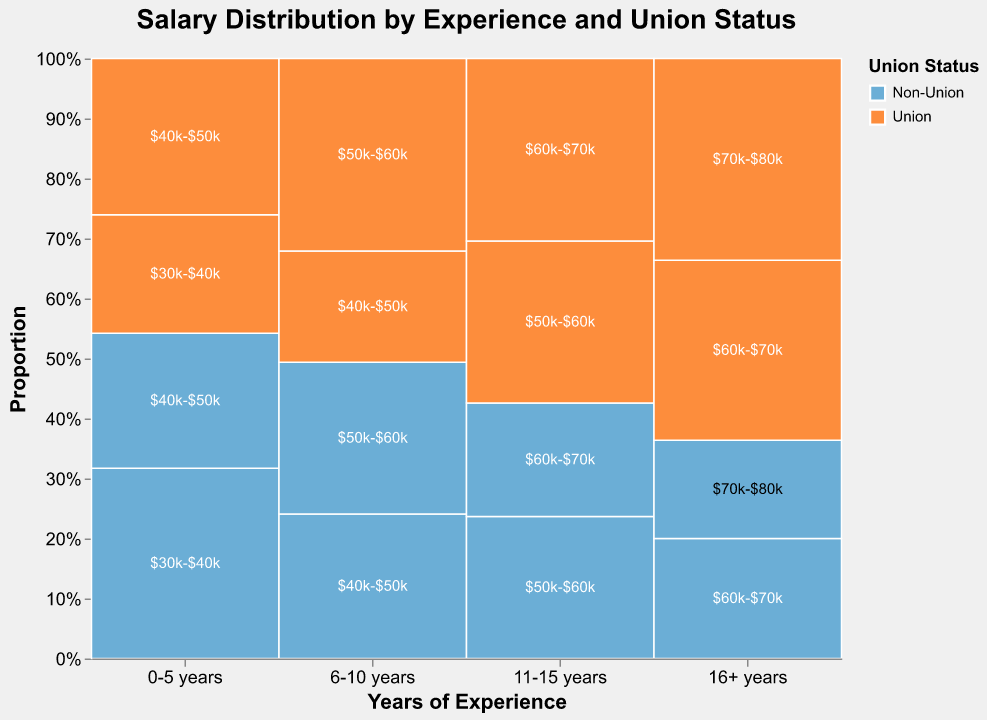what is the title of the plot? The title of the plot is located at the top of the figure and it reads: "Salary Distribution by Experience and Union Status"
Answer: Salary Distribution by Experience and Union Status what does the x-axis represent? The x-axis represents 'Years of Experience' and includes four categories: '0-5 years', '6-10 years', '11-15 years', and '16+ years'
Answer: Years of Experience what is the color scheme used for Union Status? The color scheme for Union Status uses two colors: blue for 'Non-Union' and orange for 'Union'
Answer: blue and orange how many salary ranges are represented in the 6-10 years non-union group? The tooltip shows the count of salary ranges for each experience category, and for the 6-10 years non-union group, there are two salary ranges: '$40k-$50k' and '$50k-$60k'
Answer: 2 which group has the highest count within the 0-5 years experience category? By looking at the heights of the bars within the 0-5 years category, we can see that the 'Non-Union' group with '$30k-$40k' has the highest count at 45
Answer: Non-Union $30k-$40k what is the common salary range for union members with more than 16 years of experience? The plot shows Union members with more than 16 years of experience are most commonly found in the '$70k-$80k' range with a count of 37, which is higher than the '$60k-$70k' range with a count of 33
Answer: $70k-$80k compare the salary distribution for 6-10 years experience between union and non-union members For 6-10 years of experience, Non-Union members are distributed between '$40k-$50k' (39) and '$50k-$60k' (41), whereas Union members are distributed between '$40k-$50k' (30) and '$50k-$60k' (52). Union members tend to earn more within this category
Answer: Union members tend to earn more how does the salary distribution for non-union workers evolve with experience? For Non-Union workers, the salary ranges increase with experience: '$30k-$40k' and '$40k-$50k' with 0-5 years, '$40k-$50k' and '$50k-$60k' with 6-10 years, '$50k-$60k' and '$60k-$70k' with 11-15 years, and '$60k-$70k' and '$70k-$80k' for 16+ years
Answer: Salaries increase with experience 